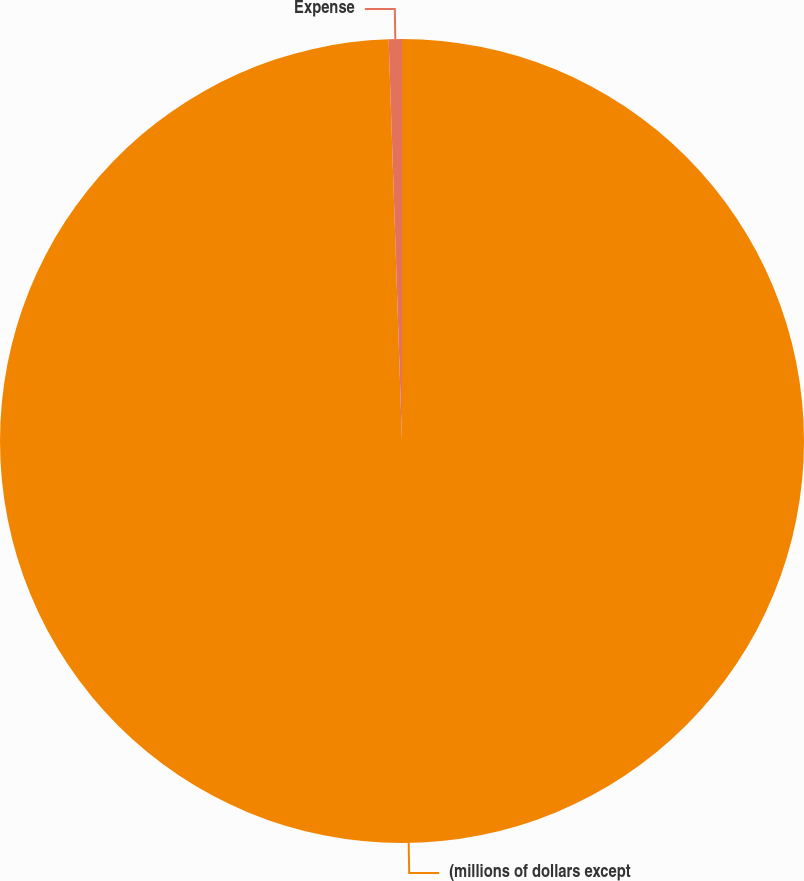<chart> <loc_0><loc_0><loc_500><loc_500><pie_chart><fcel>(millions of dollars except<fcel>Expense<nl><fcel>99.47%<fcel>0.53%<nl></chart> 